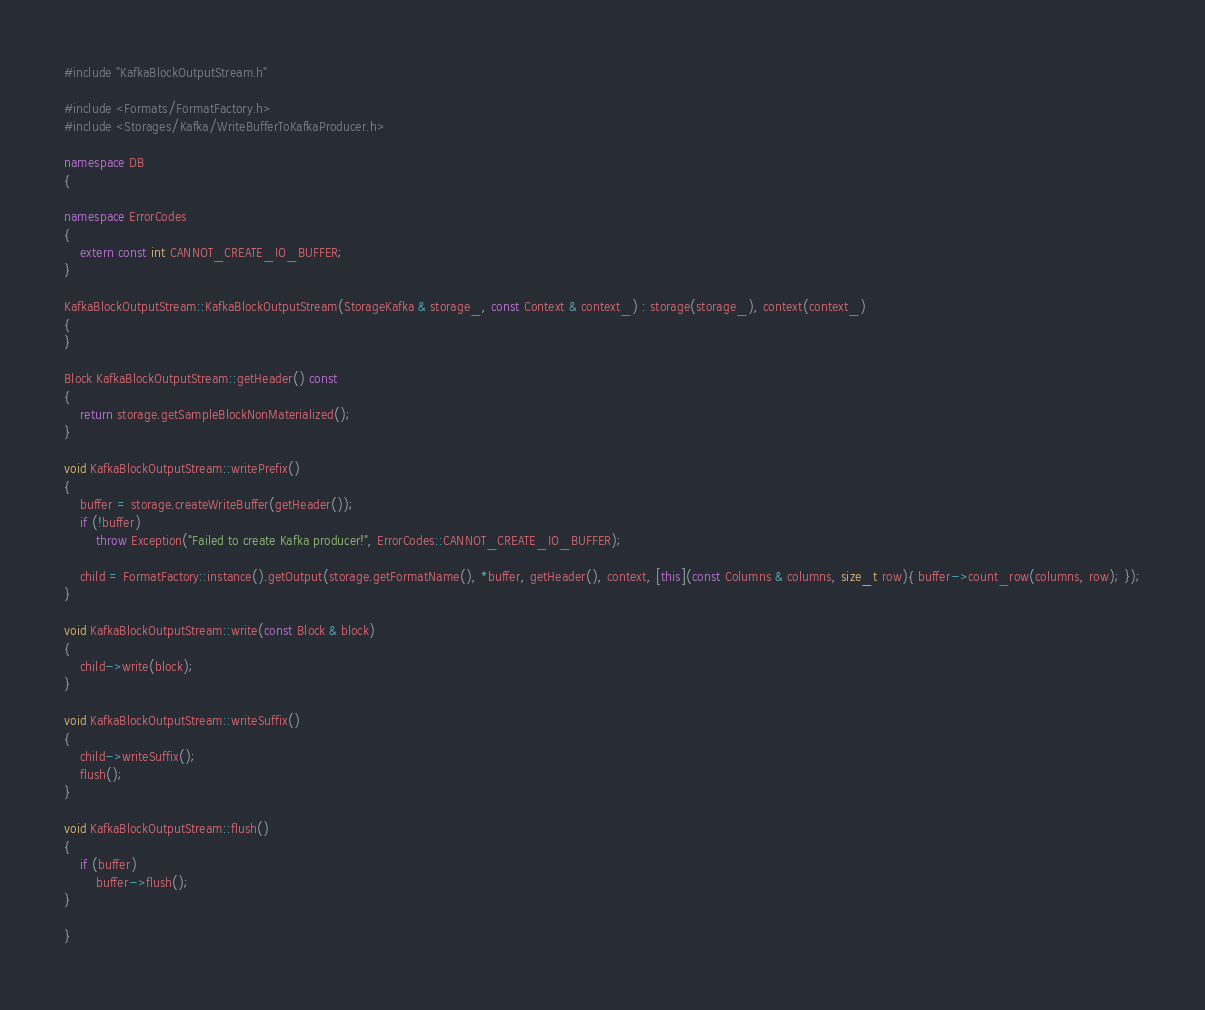<code> <loc_0><loc_0><loc_500><loc_500><_C++_>#include "KafkaBlockOutputStream.h"

#include <Formats/FormatFactory.h>
#include <Storages/Kafka/WriteBufferToKafkaProducer.h>

namespace DB
{

namespace ErrorCodes
{
    extern const int CANNOT_CREATE_IO_BUFFER;
}

KafkaBlockOutputStream::KafkaBlockOutputStream(StorageKafka & storage_, const Context & context_) : storage(storage_), context(context_)
{
}

Block KafkaBlockOutputStream::getHeader() const
{
    return storage.getSampleBlockNonMaterialized();
}

void KafkaBlockOutputStream::writePrefix()
{
    buffer = storage.createWriteBuffer(getHeader());
    if (!buffer)
        throw Exception("Failed to create Kafka producer!", ErrorCodes::CANNOT_CREATE_IO_BUFFER);

    child = FormatFactory::instance().getOutput(storage.getFormatName(), *buffer, getHeader(), context, [this](const Columns & columns, size_t row){ buffer->count_row(columns, row); });
}

void KafkaBlockOutputStream::write(const Block & block)
{
    child->write(block);
}

void KafkaBlockOutputStream::writeSuffix()
{
    child->writeSuffix();
    flush();
}

void KafkaBlockOutputStream::flush()
{
    if (buffer)
        buffer->flush();
}

}
</code> 